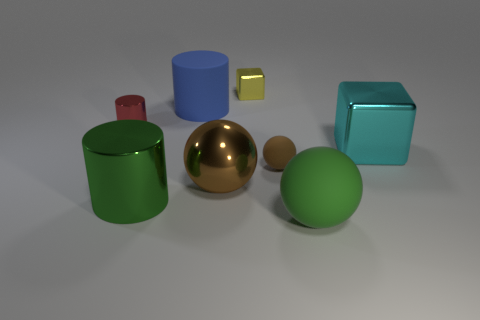Subtract all brown spheres. How many were subtracted if there are1brown spheres left? 1 Subtract all big spheres. How many spheres are left? 1 Add 2 yellow blocks. How many objects exist? 10 Subtract all yellow cylinders. How many brown balls are left? 2 Subtract all blocks. How many objects are left? 6 Subtract all cyan cylinders. Subtract all blue spheres. How many cylinders are left? 3 Subtract all matte spheres. Subtract all metal balls. How many objects are left? 5 Add 6 blue rubber cylinders. How many blue rubber cylinders are left? 7 Add 6 big metallic spheres. How many big metallic spheres exist? 7 Subtract 2 brown spheres. How many objects are left? 6 